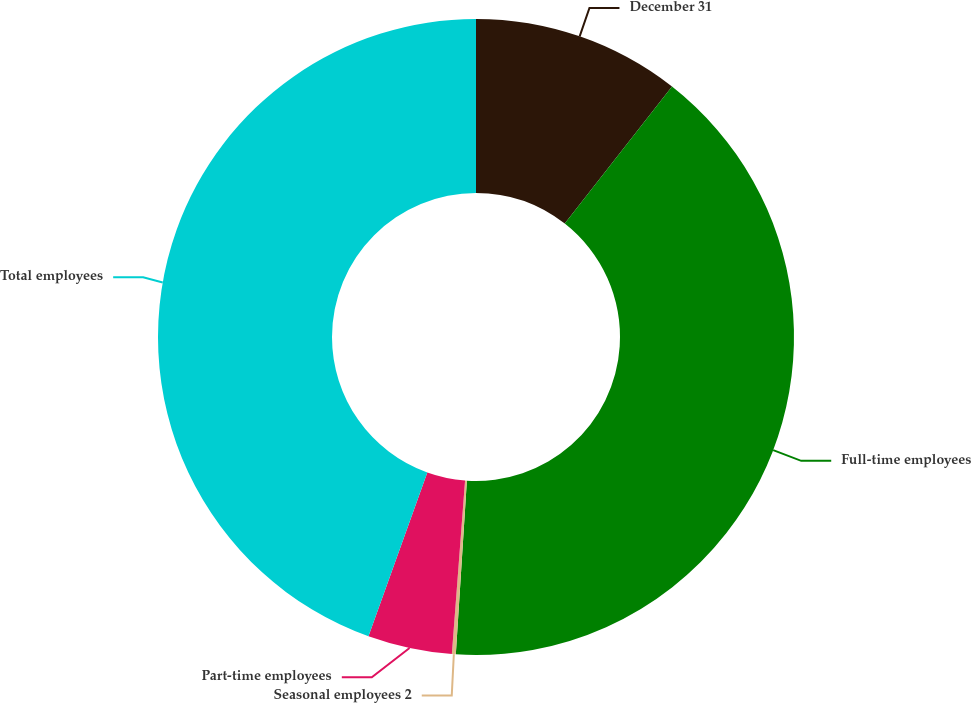Convert chart. <chart><loc_0><loc_0><loc_500><loc_500><pie_chart><fcel>December 31<fcel>Full-time employees<fcel>Seasonal employees 2<fcel>Part-time employees<fcel>Total employees<nl><fcel>10.57%<fcel>40.44%<fcel>0.2%<fcel>4.28%<fcel>44.51%<nl></chart> 